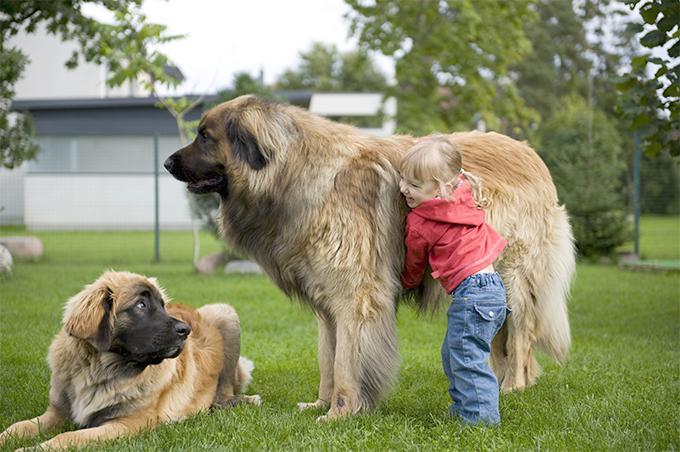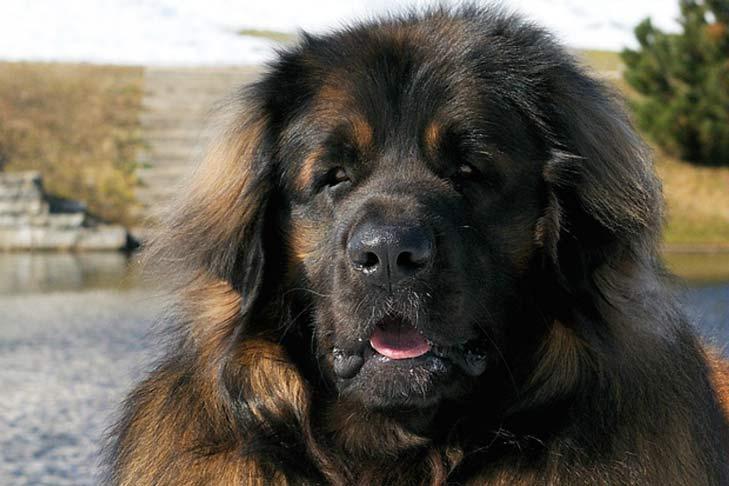The first image is the image on the left, the second image is the image on the right. Examine the images to the left and right. Is the description "There are people touching or petting a big dog with a black nose." accurate? Answer yes or no. Yes. The first image is the image on the left, the second image is the image on the right. For the images shown, is this caption "A human is standing next to a large dog." true? Answer yes or no. Yes. 